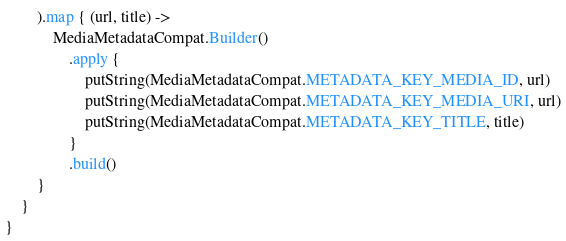<code> <loc_0><loc_0><loc_500><loc_500><_Kotlin_>        ).map { (url, title) ->
            MediaMetadataCompat.Builder()
                .apply {
                    putString(MediaMetadataCompat.METADATA_KEY_MEDIA_ID, url)
                    putString(MediaMetadataCompat.METADATA_KEY_MEDIA_URI, url)
                    putString(MediaMetadataCompat.METADATA_KEY_TITLE, title)
                }
                .build()
        }
    }
}
</code> 